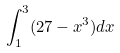Convert formula to latex. <formula><loc_0><loc_0><loc_500><loc_500>\int _ { 1 } ^ { 3 } ( 2 7 - x ^ { 3 } ) d x</formula> 